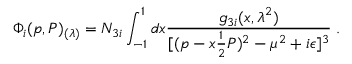<formula> <loc_0><loc_0><loc_500><loc_500>\Phi _ { i } ( p , P ) _ { ( \lambda ) } = N _ { 3 i } \int _ { - 1 } ^ { 1 } d x { \frac { g _ { 3 i } ( x , \lambda ^ { 2 } ) } { [ ( p - x { \frac { 1 } { 2 } } P ) ^ { 2 } - \mu ^ { 2 } + i \epsilon ] ^ { 3 } } } \, .</formula> 